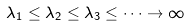<formula> <loc_0><loc_0><loc_500><loc_500>\lambda _ { 1 } \leq \lambda _ { 2 } \leq \lambda _ { 3 } \leq \dots \to \infty</formula> 